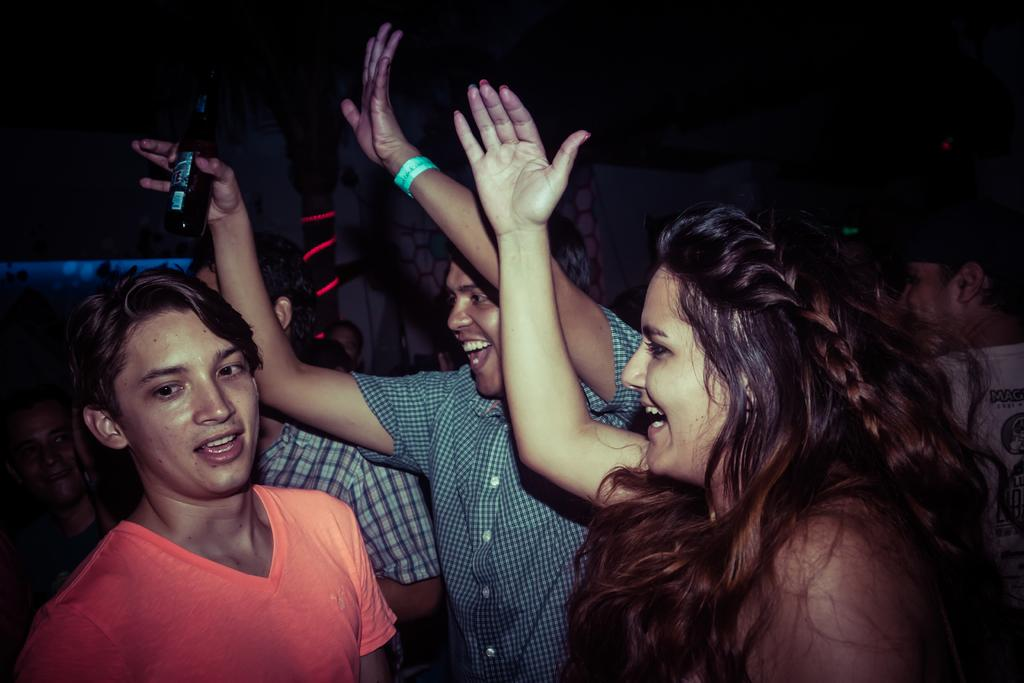What are the people in the image doing? The people in the image are dancing. Can you describe any objects being held by the people in the image? Yes, there is a person holding a wine bottle in the image. What type of wire is being used by the owner of the wine bottle in the image? There is no wire present in the image, and the concept of an owner of the wine bottle is not mentioned in the provided facts. 